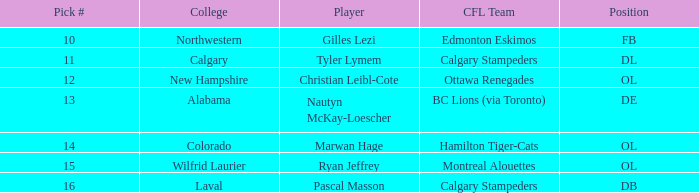What is the option number for northwestern college? 10.0. 